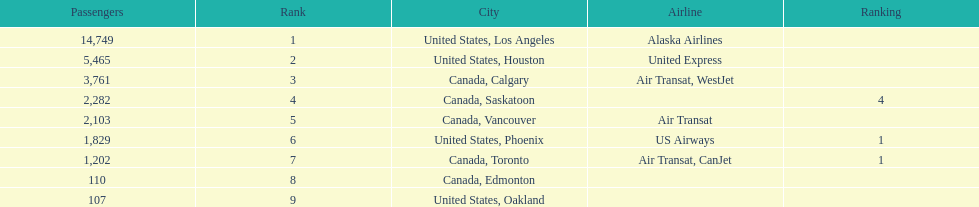The difference in passengers between los angeles and toronto 13,547. 